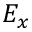Convert formula to latex. <formula><loc_0><loc_0><loc_500><loc_500>E _ { x }</formula> 